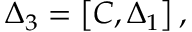Convert formula to latex. <formula><loc_0><loc_0><loc_500><loc_500>\Delta _ { 3 } = \left [ C , \Delta _ { 1 } \right ] ,</formula> 